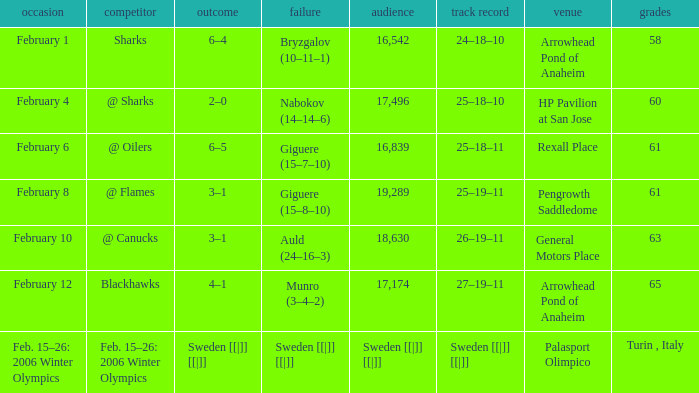What is the Arena when there were 65 points? Arrowhead Pond of Anaheim. Would you mind parsing the complete table? {'header': ['occasion', 'competitor', 'outcome', 'failure', 'audience', 'track record', 'venue', 'grades'], 'rows': [['February 1', 'Sharks', '6–4', 'Bryzgalov (10–11–1)', '16,542', '24–18–10', 'Arrowhead Pond of Anaheim', '58'], ['February 4', '@ Sharks', '2–0', 'Nabokov (14–14–6)', '17,496', '25–18–10', 'HP Pavilion at San Jose', '60'], ['February 6', '@ Oilers', '6–5', 'Giguere (15–7–10)', '16,839', '25–18–11', 'Rexall Place', '61'], ['February 8', '@ Flames', '3–1', 'Giguere (15–8–10)', '19,289', '25–19–11', 'Pengrowth Saddledome', '61'], ['February 10', '@ Canucks', '3–1', 'Auld (24–16–3)', '18,630', '26–19–11', 'General Motors Place', '63'], ['February 12', 'Blackhawks', '4–1', 'Munro (3–4–2)', '17,174', '27–19–11', 'Arrowhead Pond of Anaheim', '65'], ['Feb. 15–26: 2006 Winter Olympics', 'Feb. 15–26: 2006 Winter Olympics', 'Sweden [[|]] [[|]]', 'Sweden [[|]] [[|]]', 'Sweden [[|]] [[|]]', 'Sweden [[|]] [[|]]', 'Palasport Olimpico', 'Turin , Italy']]} 